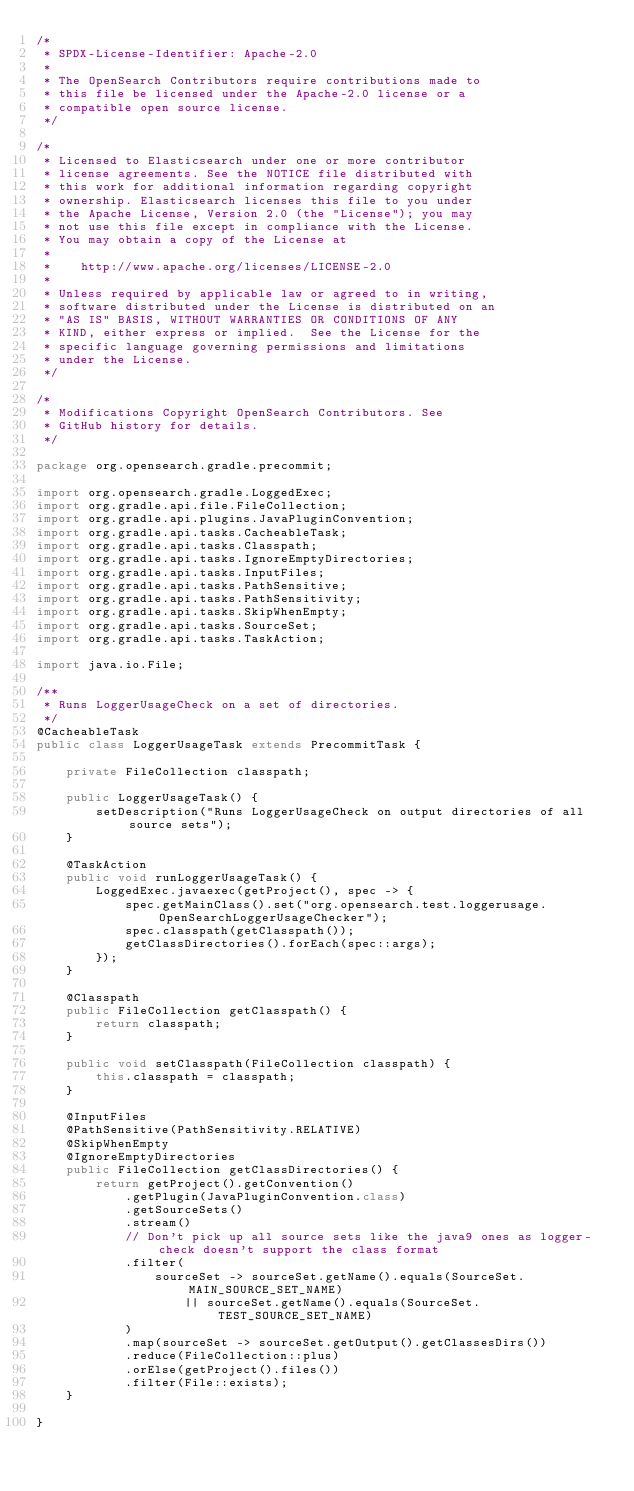Convert code to text. <code><loc_0><loc_0><loc_500><loc_500><_Java_>/*
 * SPDX-License-Identifier: Apache-2.0
 *
 * The OpenSearch Contributors require contributions made to
 * this file be licensed under the Apache-2.0 license or a
 * compatible open source license.
 */

/*
 * Licensed to Elasticsearch under one or more contributor
 * license agreements. See the NOTICE file distributed with
 * this work for additional information regarding copyright
 * ownership. Elasticsearch licenses this file to you under
 * the Apache License, Version 2.0 (the "License"); you may
 * not use this file except in compliance with the License.
 * You may obtain a copy of the License at
 *
 *    http://www.apache.org/licenses/LICENSE-2.0
 *
 * Unless required by applicable law or agreed to in writing,
 * software distributed under the License is distributed on an
 * "AS IS" BASIS, WITHOUT WARRANTIES OR CONDITIONS OF ANY
 * KIND, either express or implied.  See the License for the
 * specific language governing permissions and limitations
 * under the License.
 */

/*
 * Modifications Copyright OpenSearch Contributors. See
 * GitHub history for details.
 */

package org.opensearch.gradle.precommit;

import org.opensearch.gradle.LoggedExec;
import org.gradle.api.file.FileCollection;
import org.gradle.api.plugins.JavaPluginConvention;
import org.gradle.api.tasks.CacheableTask;
import org.gradle.api.tasks.Classpath;
import org.gradle.api.tasks.IgnoreEmptyDirectories;
import org.gradle.api.tasks.InputFiles;
import org.gradle.api.tasks.PathSensitive;
import org.gradle.api.tasks.PathSensitivity;
import org.gradle.api.tasks.SkipWhenEmpty;
import org.gradle.api.tasks.SourceSet;
import org.gradle.api.tasks.TaskAction;

import java.io.File;

/**
 * Runs LoggerUsageCheck on a set of directories.
 */
@CacheableTask
public class LoggerUsageTask extends PrecommitTask {

    private FileCollection classpath;

    public LoggerUsageTask() {
        setDescription("Runs LoggerUsageCheck on output directories of all source sets");
    }

    @TaskAction
    public void runLoggerUsageTask() {
        LoggedExec.javaexec(getProject(), spec -> {
            spec.getMainClass().set("org.opensearch.test.loggerusage.OpenSearchLoggerUsageChecker");
            spec.classpath(getClasspath());
            getClassDirectories().forEach(spec::args);
        });
    }

    @Classpath
    public FileCollection getClasspath() {
        return classpath;
    }

    public void setClasspath(FileCollection classpath) {
        this.classpath = classpath;
    }

    @InputFiles
    @PathSensitive(PathSensitivity.RELATIVE)
    @SkipWhenEmpty
    @IgnoreEmptyDirectories
    public FileCollection getClassDirectories() {
        return getProject().getConvention()
            .getPlugin(JavaPluginConvention.class)
            .getSourceSets()
            .stream()
            // Don't pick up all source sets like the java9 ones as logger-check doesn't support the class format
            .filter(
                sourceSet -> sourceSet.getName().equals(SourceSet.MAIN_SOURCE_SET_NAME)
                    || sourceSet.getName().equals(SourceSet.TEST_SOURCE_SET_NAME)
            )
            .map(sourceSet -> sourceSet.getOutput().getClassesDirs())
            .reduce(FileCollection::plus)
            .orElse(getProject().files())
            .filter(File::exists);
    }

}
</code> 